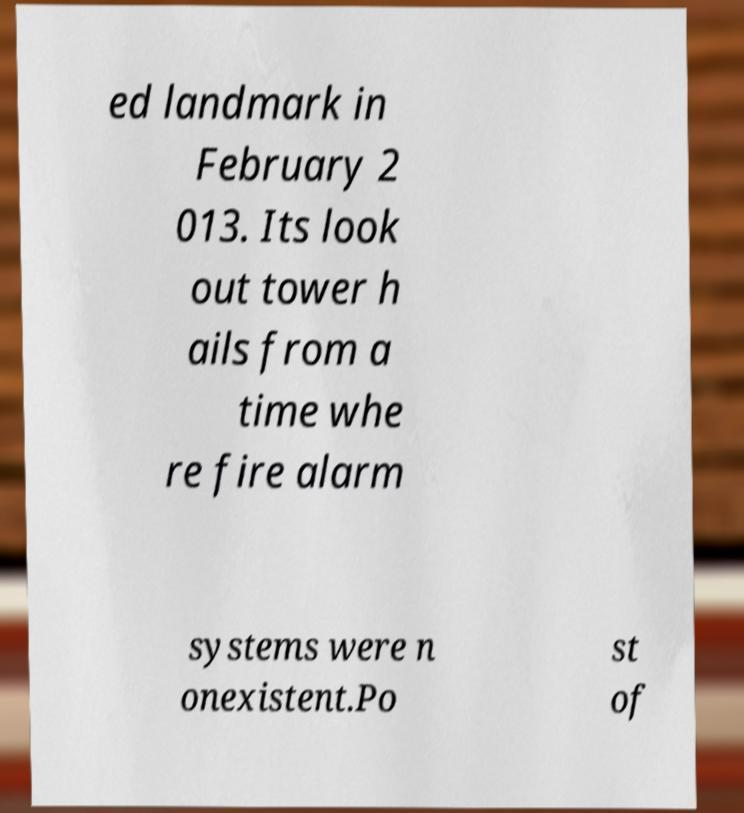For documentation purposes, I need the text within this image transcribed. Could you provide that? ed landmark in February 2 013. Its look out tower h ails from a time whe re fire alarm systems were n onexistent.Po st of 